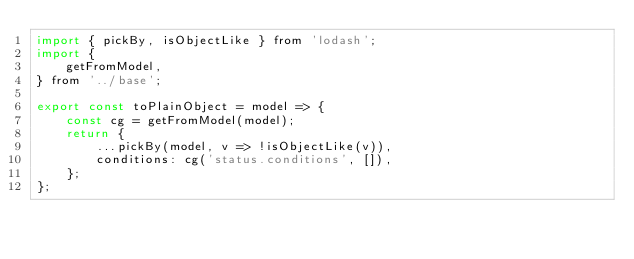Convert code to text. <code><loc_0><loc_0><loc_500><loc_500><_JavaScript_>import { pickBy, isObjectLike } from 'lodash';
import {
    getFromModel,
} from '../base';

export const toPlainObject = model => {
    const cg = getFromModel(model);
    return {
        ...pickBy(model, v => !isObjectLike(v)),
        conditions: cg('status.conditions', []),
    };
};
</code> 